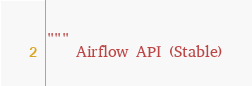<code> <loc_0><loc_0><loc_500><loc_500><_Python_>"""
    Airflow API (Stable)
</code> 